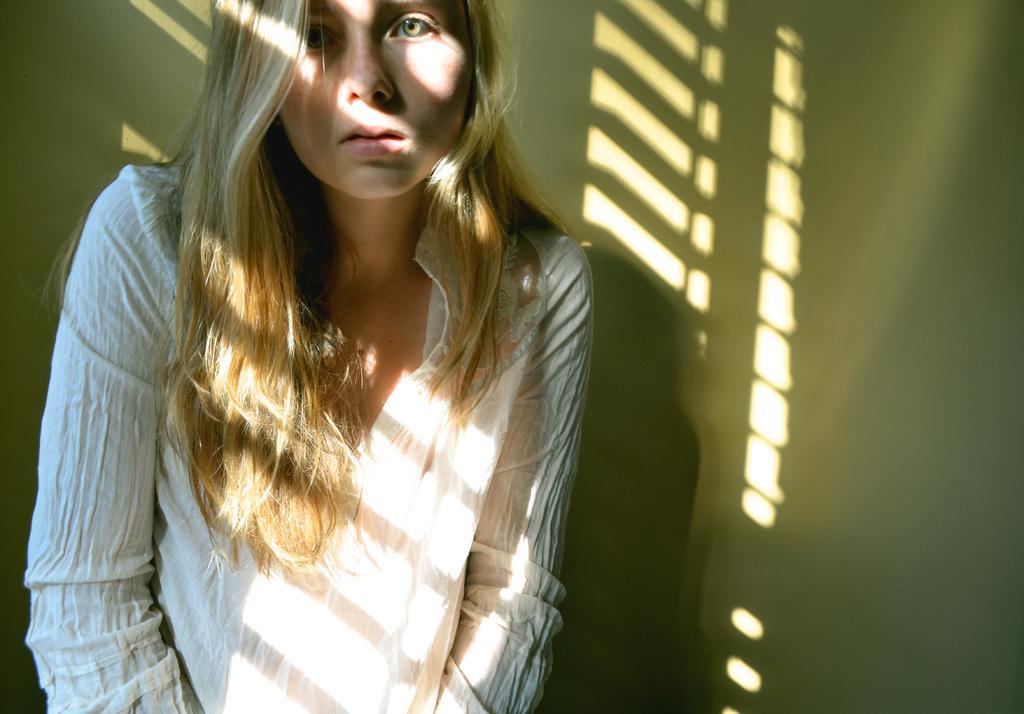Could you give a brief overview of what you see in this image? This image is taken indoors. In the background there is a wall. In the middle of the image a girl is standing and she is with a short hair. 